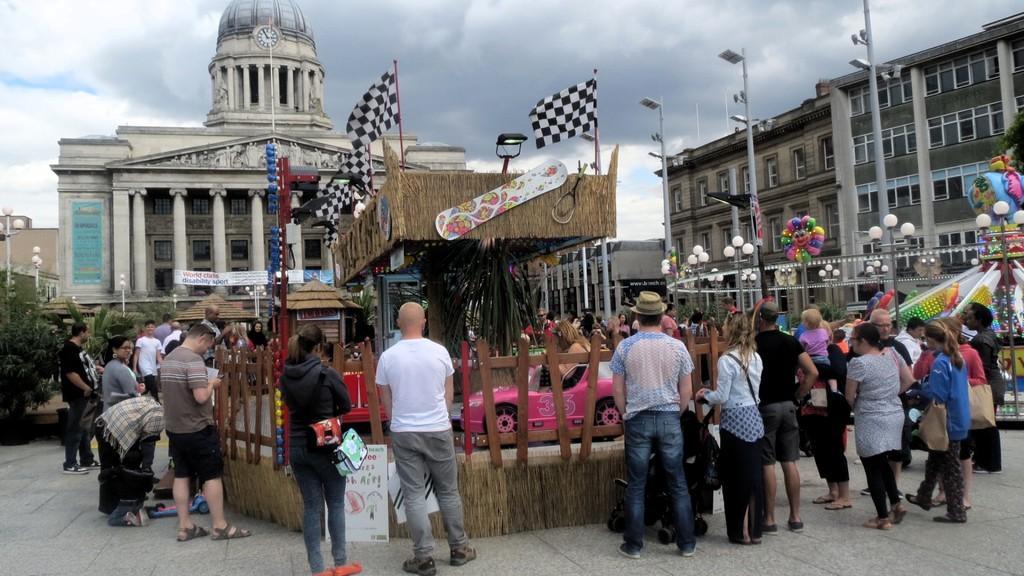How would you summarize this image in a sentence or two? In the foreground of this image, there is a hut and few toy cars moving around it. We can also see many people standing around this hut and few buildings in the background and flags on the hut. On the top, there is the sky. 